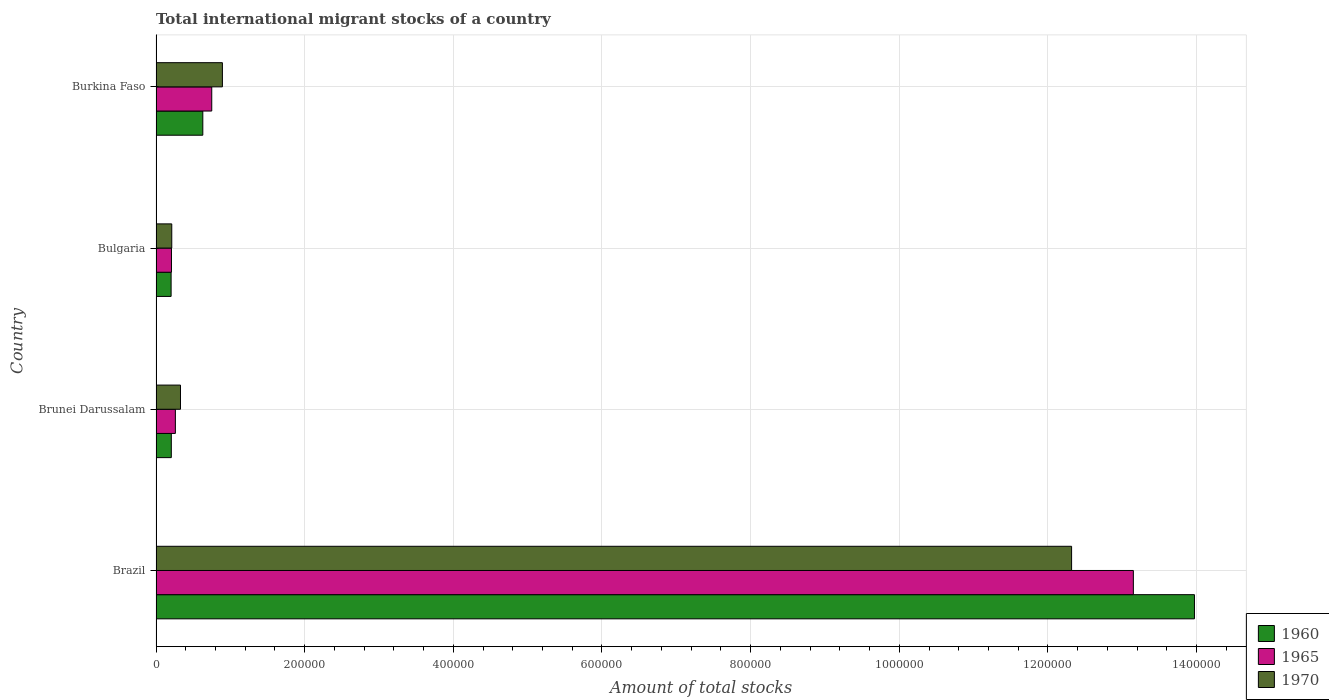How many different coloured bars are there?
Provide a succinct answer. 3. How many bars are there on the 2nd tick from the bottom?
Provide a short and direct response. 3. What is the amount of total stocks in in 1965 in Brazil?
Your response must be concise. 1.31e+06. Across all countries, what is the maximum amount of total stocks in in 1965?
Provide a succinct answer. 1.31e+06. Across all countries, what is the minimum amount of total stocks in in 1970?
Give a very brief answer. 2.12e+04. In which country was the amount of total stocks in in 1965 maximum?
Offer a very short reply. Brazil. In which country was the amount of total stocks in in 1960 minimum?
Your response must be concise. Bulgaria. What is the total amount of total stocks in in 1970 in the graph?
Give a very brief answer. 1.38e+06. What is the difference between the amount of total stocks in in 1970 in Brunei Darussalam and that in Burkina Faso?
Your answer should be very brief. -5.64e+04. What is the difference between the amount of total stocks in in 1960 in Brunei Darussalam and the amount of total stocks in in 1970 in Brazil?
Provide a succinct answer. -1.21e+06. What is the average amount of total stocks in in 1960 per country?
Your response must be concise. 3.75e+05. What is the difference between the amount of total stocks in in 1960 and amount of total stocks in in 1965 in Bulgaria?
Give a very brief answer. -488. In how many countries, is the amount of total stocks in in 1960 greater than 80000 ?
Provide a succinct answer. 1. What is the ratio of the amount of total stocks in in 1960 in Brazil to that in Burkina Faso?
Provide a short and direct response. 22.2. Is the amount of total stocks in in 1970 in Brazil less than that in Bulgaria?
Your answer should be very brief. No. What is the difference between the highest and the second highest amount of total stocks in in 1960?
Your answer should be compact. 1.33e+06. What is the difference between the highest and the lowest amount of total stocks in in 1960?
Make the answer very short. 1.38e+06. Is the sum of the amount of total stocks in in 1970 in Brazil and Burkina Faso greater than the maximum amount of total stocks in in 1965 across all countries?
Offer a very short reply. Yes. What does the 3rd bar from the top in Burkina Faso represents?
Keep it short and to the point. 1960. What does the 2nd bar from the bottom in Bulgaria represents?
Your response must be concise. 1965. How many bars are there?
Offer a very short reply. 12. How many countries are there in the graph?
Provide a short and direct response. 4. What is the difference between two consecutive major ticks on the X-axis?
Offer a very short reply. 2.00e+05. Does the graph contain any zero values?
Provide a short and direct response. No. Where does the legend appear in the graph?
Keep it short and to the point. Bottom right. How are the legend labels stacked?
Ensure brevity in your answer.  Vertical. What is the title of the graph?
Provide a short and direct response. Total international migrant stocks of a country. Does "2009" appear as one of the legend labels in the graph?
Your response must be concise. No. What is the label or title of the X-axis?
Provide a succinct answer. Amount of total stocks. What is the Amount of total stocks in 1960 in Brazil?
Keep it short and to the point. 1.40e+06. What is the Amount of total stocks of 1965 in Brazil?
Your answer should be very brief. 1.31e+06. What is the Amount of total stocks in 1970 in Brazil?
Offer a terse response. 1.23e+06. What is the Amount of total stocks in 1960 in Brunei Darussalam?
Provide a short and direct response. 2.06e+04. What is the Amount of total stocks of 1965 in Brunei Darussalam?
Provide a succinct answer. 2.60e+04. What is the Amount of total stocks of 1970 in Brunei Darussalam?
Provide a succinct answer. 3.29e+04. What is the Amount of total stocks of 1960 in Bulgaria?
Your answer should be very brief. 2.03e+04. What is the Amount of total stocks in 1965 in Bulgaria?
Offer a terse response. 2.08e+04. What is the Amount of total stocks of 1970 in Bulgaria?
Give a very brief answer. 2.12e+04. What is the Amount of total stocks in 1960 in Burkina Faso?
Make the answer very short. 6.29e+04. What is the Amount of total stocks of 1965 in Burkina Faso?
Offer a very short reply. 7.50e+04. What is the Amount of total stocks in 1970 in Burkina Faso?
Provide a succinct answer. 8.93e+04. Across all countries, what is the maximum Amount of total stocks of 1960?
Provide a succinct answer. 1.40e+06. Across all countries, what is the maximum Amount of total stocks of 1965?
Your answer should be very brief. 1.31e+06. Across all countries, what is the maximum Amount of total stocks in 1970?
Ensure brevity in your answer.  1.23e+06. Across all countries, what is the minimum Amount of total stocks in 1960?
Give a very brief answer. 2.03e+04. Across all countries, what is the minimum Amount of total stocks in 1965?
Ensure brevity in your answer.  2.08e+04. Across all countries, what is the minimum Amount of total stocks of 1970?
Offer a terse response. 2.12e+04. What is the total Amount of total stocks in 1960 in the graph?
Ensure brevity in your answer.  1.50e+06. What is the total Amount of total stocks of 1965 in the graph?
Make the answer very short. 1.44e+06. What is the total Amount of total stocks in 1970 in the graph?
Offer a terse response. 1.38e+06. What is the difference between the Amount of total stocks of 1960 in Brazil and that in Brunei Darussalam?
Give a very brief answer. 1.38e+06. What is the difference between the Amount of total stocks in 1965 in Brazil and that in Brunei Darussalam?
Offer a very short reply. 1.29e+06. What is the difference between the Amount of total stocks of 1970 in Brazil and that in Brunei Darussalam?
Make the answer very short. 1.20e+06. What is the difference between the Amount of total stocks in 1960 in Brazil and that in Bulgaria?
Keep it short and to the point. 1.38e+06. What is the difference between the Amount of total stocks of 1965 in Brazil and that in Bulgaria?
Offer a terse response. 1.29e+06. What is the difference between the Amount of total stocks of 1970 in Brazil and that in Bulgaria?
Your response must be concise. 1.21e+06. What is the difference between the Amount of total stocks of 1960 in Brazil and that in Burkina Faso?
Your response must be concise. 1.33e+06. What is the difference between the Amount of total stocks of 1965 in Brazil and that in Burkina Faso?
Give a very brief answer. 1.24e+06. What is the difference between the Amount of total stocks in 1970 in Brazil and that in Burkina Faso?
Make the answer very short. 1.14e+06. What is the difference between the Amount of total stocks in 1960 in Brunei Darussalam and that in Bulgaria?
Keep it short and to the point. 267. What is the difference between the Amount of total stocks of 1965 in Brunei Darussalam and that in Bulgaria?
Give a very brief answer. 5255. What is the difference between the Amount of total stocks in 1970 in Brunei Darussalam and that in Bulgaria?
Your answer should be very brief. 1.17e+04. What is the difference between the Amount of total stocks of 1960 in Brunei Darussalam and that in Burkina Faso?
Ensure brevity in your answer.  -4.24e+04. What is the difference between the Amount of total stocks in 1965 in Brunei Darussalam and that in Burkina Faso?
Provide a succinct answer. -4.89e+04. What is the difference between the Amount of total stocks of 1970 in Brunei Darussalam and that in Burkina Faso?
Make the answer very short. -5.64e+04. What is the difference between the Amount of total stocks of 1960 in Bulgaria and that in Burkina Faso?
Provide a short and direct response. -4.26e+04. What is the difference between the Amount of total stocks of 1965 in Bulgaria and that in Burkina Faso?
Make the answer very short. -5.42e+04. What is the difference between the Amount of total stocks in 1970 in Bulgaria and that in Burkina Faso?
Offer a very short reply. -6.81e+04. What is the difference between the Amount of total stocks in 1960 in Brazil and the Amount of total stocks in 1965 in Brunei Darussalam?
Offer a terse response. 1.37e+06. What is the difference between the Amount of total stocks in 1960 in Brazil and the Amount of total stocks in 1970 in Brunei Darussalam?
Give a very brief answer. 1.36e+06. What is the difference between the Amount of total stocks in 1965 in Brazil and the Amount of total stocks in 1970 in Brunei Darussalam?
Ensure brevity in your answer.  1.28e+06. What is the difference between the Amount of total stocks in 1960 in Brazil and the Amount of total stocks in 1965 in Bulgaria?
Offer a terse response. 1.38e+06. What is the difference between the Amount of total stocks of 1960 in Brazil and the Amount of total stocks of 1970 in Bulgaria?
Your answer should be compact. 1.38e+06. What is the difference between the Amount of total stocks of 1965 in Brazil and the Amount of total stocks of 1970 in Bulgaria?
Provide a short and direct response. 1.29e+06. What is the difference between the Amount of total stocks in 1960 in Brazil and the Amount of total stocks in 1965 in Burkina Faso?
Provide a succinct answer. 1.32e+06. What is the difference between the Amount of total stocks in 1960 in Brazil and the Amount of total stocks in 1970 in Burkina Faso?
Keep it short and to the point. 1.31e+06. What is the difference between the Amount of total stocks of 1965 in Brazil and the Amount of total stocks of 1970 in Burkina Faso?
Make the answer very short. 1.23e+06. What is the difference between the Amount of total stocks of 1960 in Brunei Darussalam and the Amount of total stocks of 1965 in Bulgaria?
Offer a terse response. -221. What is the difference between the Amount of total stocks in 1960 in Brunei Darussalam and the Amount of total stocks in 1970 in Bulgaria?
Provide a succinct answer. -627. What is the difference between the Amount of total stocks of 1965 in Brunei Darussalam and the Amount of total stocks of 1970 in Bulgaria?
Your response must be concise. 4849. What is the difference between the Amount of total stocks in 1960 in Brunei Darussalam and the Amount of total stocks in 1965 in Burkina Faso?
Provide a short and direct response. -5.44e+04. What is the difference between the Amount of total stocks in 1960 in Brunei Darussalam and the Amount of total stocks in 1970 in Burkina Faso?
Your response must be concise. -6.88e+04. What is the difference between the Amount of total stocks of 1965 in Brunei Darussalam and the Amount of total stocks of 1970 in Burkina Faso?
Make the answer very short. -6.33e+04. What is the difference between the Amount of total stocks in 1960 in Bulgaria and the Amount of total stocks in 1965 in Burkina Faso?
Keep it short and to the point. -5.47e+04. What is the difference between the Amount of total stocks of 1960 in Bulgaria and the Amount of total stocks of 1970 in Burkina Faso?
Your answer should be compact. -6.90e+04. What is the difference between the Amount of total stocks in 1965 in Bulgaria and the Amount of total stocks in 1970 in Burkina Faso?
Offer a terse response. -6.85e+04. What is the average Amount of total stocks of 1960 per country?
Give a very brief answer. 3.75e+05. What is the average Amount of total stocks in 1965 per country?
Give a very brief answer. 3.59e+05. What is the average Amount of total stocks of 1970 per country?
Make the answer very short. 3.44e+05. What is the difference between the Amount of total stocks of 1960 and Amount of total stocks of 1965 in Brazil?
Give a very brief answer. 8.22e+04. What is the difference between the Amount of total stocks of 1960 and Amount of total stocks of 1970 in Brazil?
Offer a very short reply. 1.65e+05. What is the difference between the Amount of total stocks of 1965 and Amount of total stocks of 1970 in Brazil?
Your answer should be very brief. 8.31e+04. What is the difference between the Amount of total stocks in 1960 and Amount of total stocks in 1965 in Brunei Darussalam?
Provide a short and direct response. -5476. What is the difference between the Amount of total stocks in 1960 and Amount of total stocks in 1970 in Brunei Darussalam?
Ensure brevity in your answer.  -1.23e+04. What is the difference between the Amount of total stocks in 1965 and Amount of total stocks in 1970 in Brunei Darussalam?
Your answer should be very brief. -6865. What is the difference between the Amount of total stocks in 1960 and Amount of total stocks in 1965 in Bulgaria?
Provide a short and direct response. -488. What is the difference between the Amount of total stocks of 1960 and Amount of total stocks of 1970 in Bulgaria?
Provide a succinct answer. -894. What is the difference between the Amount of total stocks of 1965 and Amount of total stocks of 1970 in Bulgaria?
Offer a terse response. -406. What is the difference between the Amount of total stocks in 1960 and Amount of total stocks in 1965 in Burkina Faso?
Keep it short and to the point. -1.20e+04. What is the difference between the Amount of total stocks in 1960 and Amount of total stocks in 1970 in Burkina Faso?
Your answer should be compact. -2.64e+04. What is the difference between the Amount of total stocks in 1965 and Amount of total stocks in 1970 in Burkina Faso?
Keep it short and to the point. -1.43e+04. What is the ratio of the Amount of total stocks in 1960 in Brazil to that in Brunei Darussalam?
Make the answer very short. 67.95. What is the ratio of the Amount of total stocks of 1965 in Brazil to that in Brunei Darussalam?
Ensure brevity in your answer.  50.5. What is the ratio of the Amount of total stocks in 1970 in Brazil to that in Brunei Darussalam?
Provide a short and direct response. 37.44. What is the ratio of the Amount of total stocks of 1960 in Brazil to that in Bulgaria?
Offer a terse response. 68.84. What is the ratio of the Amount of total stocks of 1965 in Brazil to that in Bulgaria?
Give a very brief answer. 63.27. What is the ratio of the Amount of total stocks of 1970 in Brazil to that in Bulgaria?
Provide a succinct answer. 58.14. What is the ratio of the Amount of total stocks in 1960 in Brazil to that in Burkina Faso?
Your answer should be compact. 22.2. What is the ratio of the Amount of total stocks in 1965 in Brazil to that in Burkina Faso?
Provide a short and direct response. 17.54. What is the ratio of the Amount of total stocks of 1970 in Brazil to that in Burkina Faso?
Offer a very short reply. 13.79. What is the ratio of the Amount of total stocks in 1960 in Brunei Darussalam to that in Bulgaria?
Make the answer very short. 1.01. What is the ratio of the Amount of total stocks of 1965 in Brunei Darussalam to that in Bulgaria?
Offer a terse response. 1.25. What is the ratio of the Amount of total stocks in 1970 in Brunei Darussalam to that in Bulgaria?
Provide a succinct answer. 1.55. What is the ratio of the Amount of total stocks of 1960 in Brunei Darussalam to that in Burkina Faso?
Provide a short and direct response. 0.33. What is the ratio of the Amount of total stocks of 1965 in Brunei Darussalam to that in Burkina Faso?
Provide a short and direct response. 0.35. What is the ratio of the Amount of total stocks of 1970 in Brunei Darussalam to that in Burkina Faso?
Ensure brevity in your answer.  0.37. What is the ratio of the Amount of total stocks of 1960 in Bulgaria to that in Burkina Faso?
Offer a very short reply. 0.32. What is the ratio of the Amount of total stocks in 1965 in Bulgaria to that in Burkina Faso?
Your answer should be compact. 0.28. What is the ratio of the Amount of total stocks of 1970 in Bulgaria to that in Burkina Faso?
Offer a very short reply. 0.24. What is the difference between the highest and the second highest Amount of total stocks in 1960?
Give a very brief answer. 1.33e+06. What is the difference between the highest and the second highest Amount of total stocks of 1965?
Your answer should be compact. 1.24e+06. What is the difference between the highest and the second highest Amount of total stocks of 1970?
Offer a very short reply. 1.14e+06. What is the difference between the highest and the lowest Amount of total stocks of 1960?
Your answer should be compact. 1.38e+06. What is the difference between the highest and the lowest Amount of total stocks in 1965?
Your answer should be compact. 1.29e+06. What is the difference between the highest and the lowest Amount of total stocks in 1970?
Your answer should be compact. 1.21e+06. 